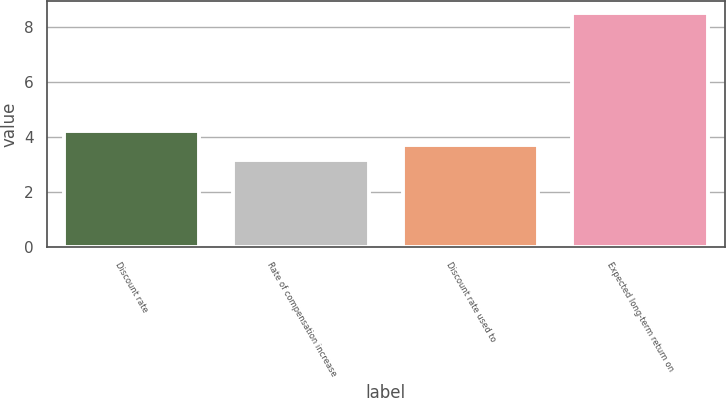Convert chart to OTSL. <chart><loc_0><loc_0><loc_500><loc_500><bar_chart><fcel>Discount rate<fcel>Rate of compensation increase<fcel>Discount rate used to<fcel>Expected long-term return on<nl><fcel>4.22<fcel>3.15<fcel>3.69<fcel>8.5<nl></chart> 